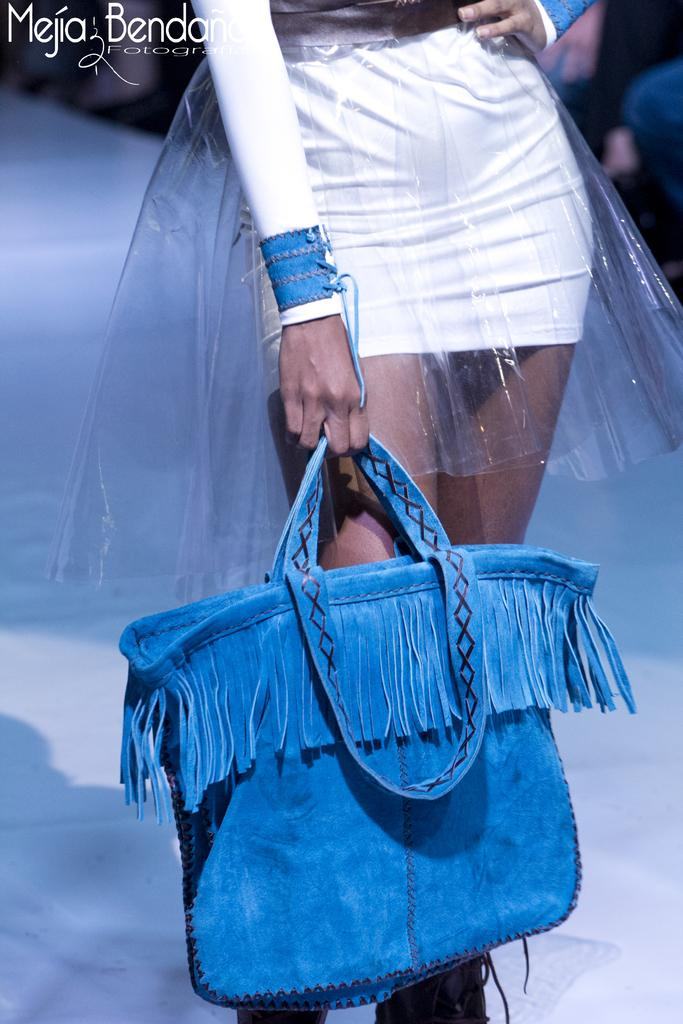What is the main subject of the image? The main subject of the image is a woman. Can you describe what the woman is wearing? The woman is wearing a white dress. What object is the woman holding in her hand? The woman is holding a blue bag in her hand. What type of bubble can be seen floating around the woman in the image? There is no bubble present in the image. What type of harmony is the woman trying to achieve in the image? The image does not depict any specific harmony or goal; it simply shows a woman wearing a white dress and holding a blue bag. --- Facts: 1. There is a car in the image. 2. The car is red. 3. The car has four wheels. 4. There are people sitting inside the car. 5. The car is parked on the side of the road. Absurd Topics: parrot, sandcastle, volcano Conversation: What is the main subject of the image? The main subject of the image is a car. Can you describe the color of the car? The car is red. How many wheels does the car have? The car has four wheels. What are the people inside the car doing? The provided facts do not specify what the people inside the car are doing. Where is the car located in the image? The car is parked on the side of the road. Reasoning: Let's think step by step in order to produce the conversation. We start by identifying the main subject of the image, which is the car. Next, we describe the color of the car, which is red. Then, we observe the number of wheels the car has, which is four. Finally, we describe the location of the car, which is parked on the side of the road. Absurd Question/Answer: Can you tell me how many parrots are sitting on the roof of the car in the image? There are no parrots present on the roof of the car in the image. What type of sandcastle can be seen being built by the people inside the car? There is no sandcastle present in the image. 